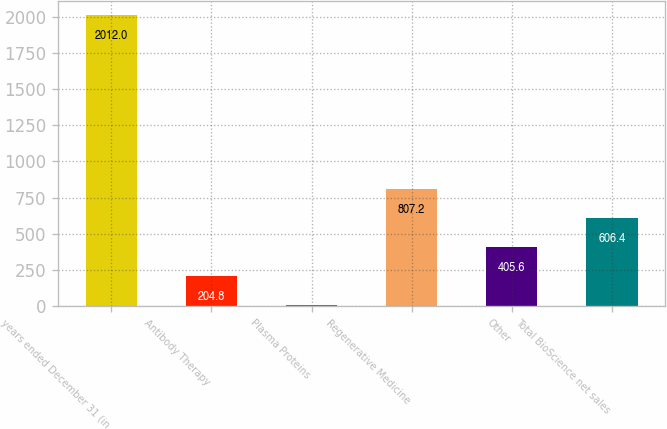Convert chart. <chart><loc_0><loc_0><loc_500><loc_500><bar_chart><fcel>years ended December 31 (in<fcel>Antibody Therapy<fcel>Plasma Proteins<fcel>Regenerative Medicine<fcel>Other<fcel>Total BioScience net sales<nl><fcel>2012<fcel>204.8<fcel>4<fcel>807.2<fcel>405.6<fcel>606.4<nl></chart> 